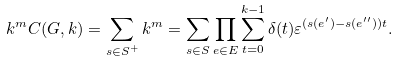<formula> <loc_0><loc_0><loc_500><loc_500>k ^ { m } C ( G , k ) = \sum _ { s \in S ^ { + } } k ^ { m } = \sum _ { s \in S } \prod _ { e \in E } \sum _ { t = 0 } ^ { k - 1 } \delta ( t ) \varepsilon ^ { ( s ( e ^ { \prime } ) - s ( e ^ { \prime \prime } ) ) t } .</formula> 